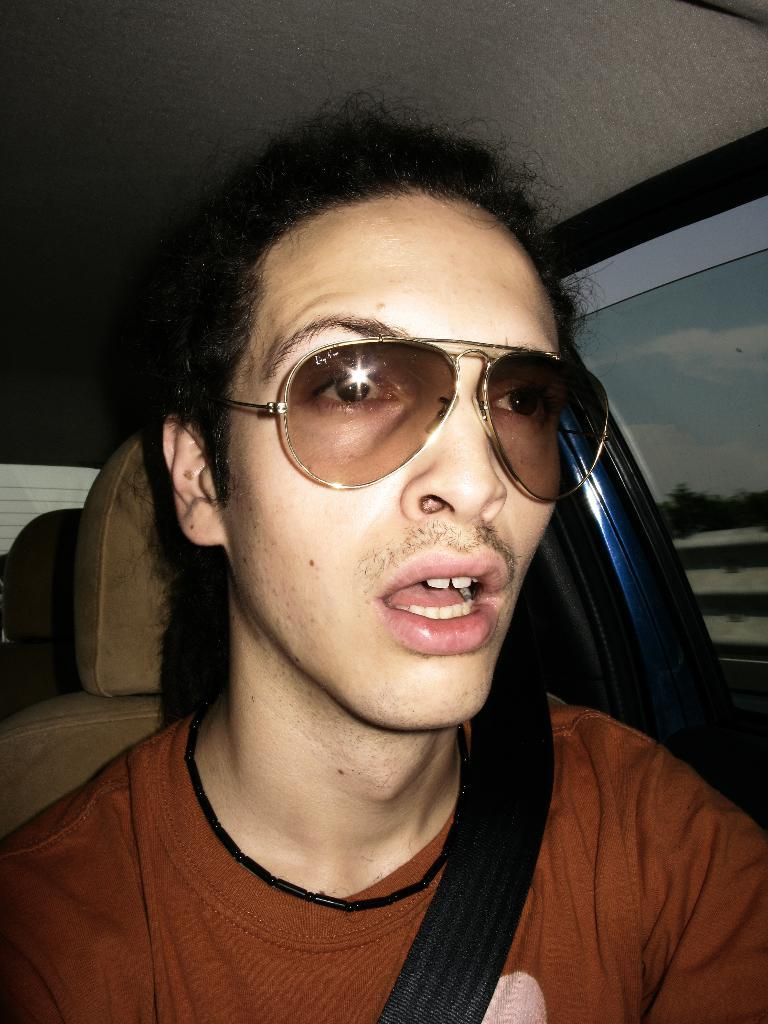Who or what is present in the image? There is a person in the image. What is the person wearing? The person is wearing goggles. Where is the person located? The person is sitting inside a vehicle. What type of smoke can be seen coming from the mine in the image? There is no mine or smoke present in the image; it features a person wearing goggles and sitting inside a vehicle. 